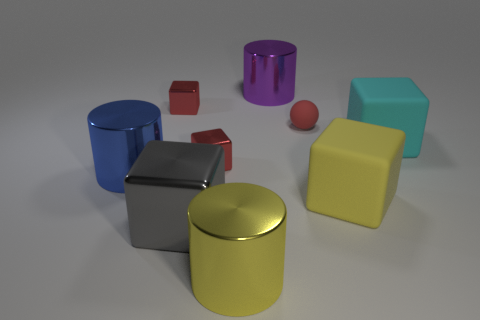Subtract all large cyan cubes. How many cubes are left? 4 Subtract all red cubes. How many cubes are left? 3 Subtract 1 cubes. How many cubes are left? 4 Subtract all yellow cubes. Subtract all green cylinders. How many cubes are left? 4 Add 1 large yellow rubber things. How many objects exist? 10 Subtract all balls. How many objects are left? 8 Add 4 big purple objects. How many big purple objects exist? 5 Subtract 1 yellow cylinders. How many objects are left? 8 Subtract all big cyan blocks. Subtract all large shiny things. How many objects are left? 4 Add 2 tiny rubber balls. How many tiny rubber balls are left? 3 